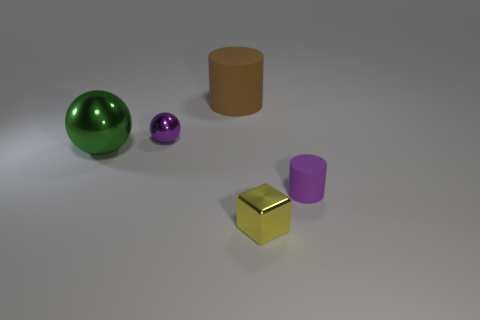Add 3 purple spheres. How many objects exist? 8 Subtract all blocks. How many objects are left? 4 Add 4 spheres. How many spheres are left? 6 Add 4 tiny metallic balls. How many tiny metallic balls exist? 5 Subtract 0 red cylinders. How many objects are left? 5 Subtract all gray metal objects. Subtract all tiny cylinders. How many objects are left? 4 